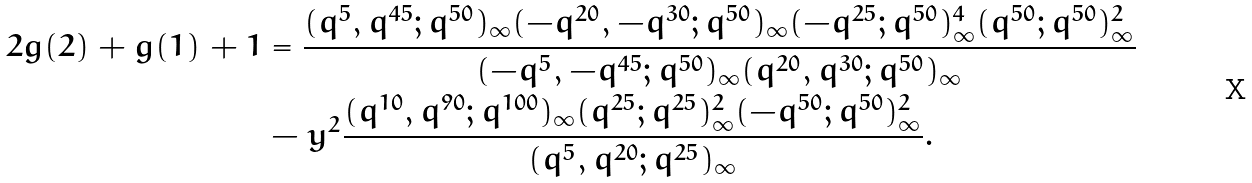<formula> <loc_0><loc_0><loc_500><loc_500>2 g ( 2 ) + g ( 1 ) + 1 & = \frac { ( q ^ { 5 } , q ^ { 4 5 } ; q ^ { 5 0 } ) _ { \infty } ( - q ^ { 2 0 } , - q ^ { 3 0 } ; q ^ { 5 0 } ) _ { \infty } ( - q ^ { 2 5 } ; q ^ { 5 0 } ) _ { \infty } ^ { 4 } ( q ^ { 5 0 } ; q ^ { 5 0 } ) _ { \infty } ^ { 2 } } { ( - q ^ { 5 } , - q ^ { 4 5 } ; q ^ { 5 0 } ) _ { \infty } ( q ^ { 2 0 } , q ^ { 3 0 } ; q ^ { 5 0 } ) _ { \infty } } \\ & - y ^ { 2 } \frac { ( q ^ { 1 0 } , q ^ { 9 0 } ; q ^ { 1 0 0 } ) _ { \infty } ( q ^ { 2 5 } ; q ^ { 2 5 } ) _ { \infty } ^ { 2 } ( - q ^ { 5 0 } ; q ^ { 5 0 } ) _ { \infty } ^ { 2 } } { ( q ^ { 5 } , q ^ { 2 0 } ; q ^ { 2 5 } ) _ { \infty } } .</formula> 